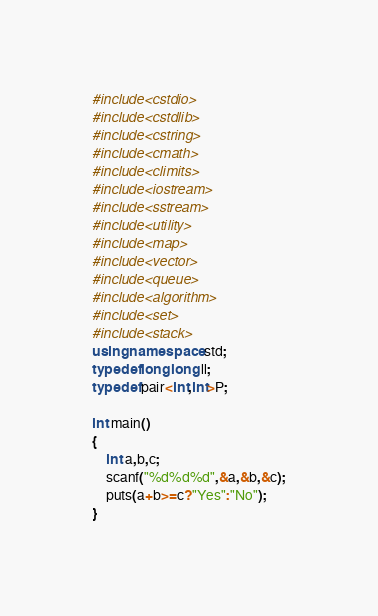Convert code to text. <code><loc_0><loc_0><loc_500><loc_500><_C++_>#include<cstdio>
#include<cstdlib>
#include<cstring>
#include<cmath>
#include<climits>
#include<iostream>
#include<sstream>
#include<utility>
#include<map>
#include<vector>
#include<queue>
#include<algorithm>
#include<set>
#include<stack>
using namespace std;
typedef long long ll;
typedef pair<int,int>P;

int main()
{
	int a,b,c;
	scanf("%d%d%d",&a,&b,&c);
	puts(a+b>=c?"Yes":"No");
}
</code> 